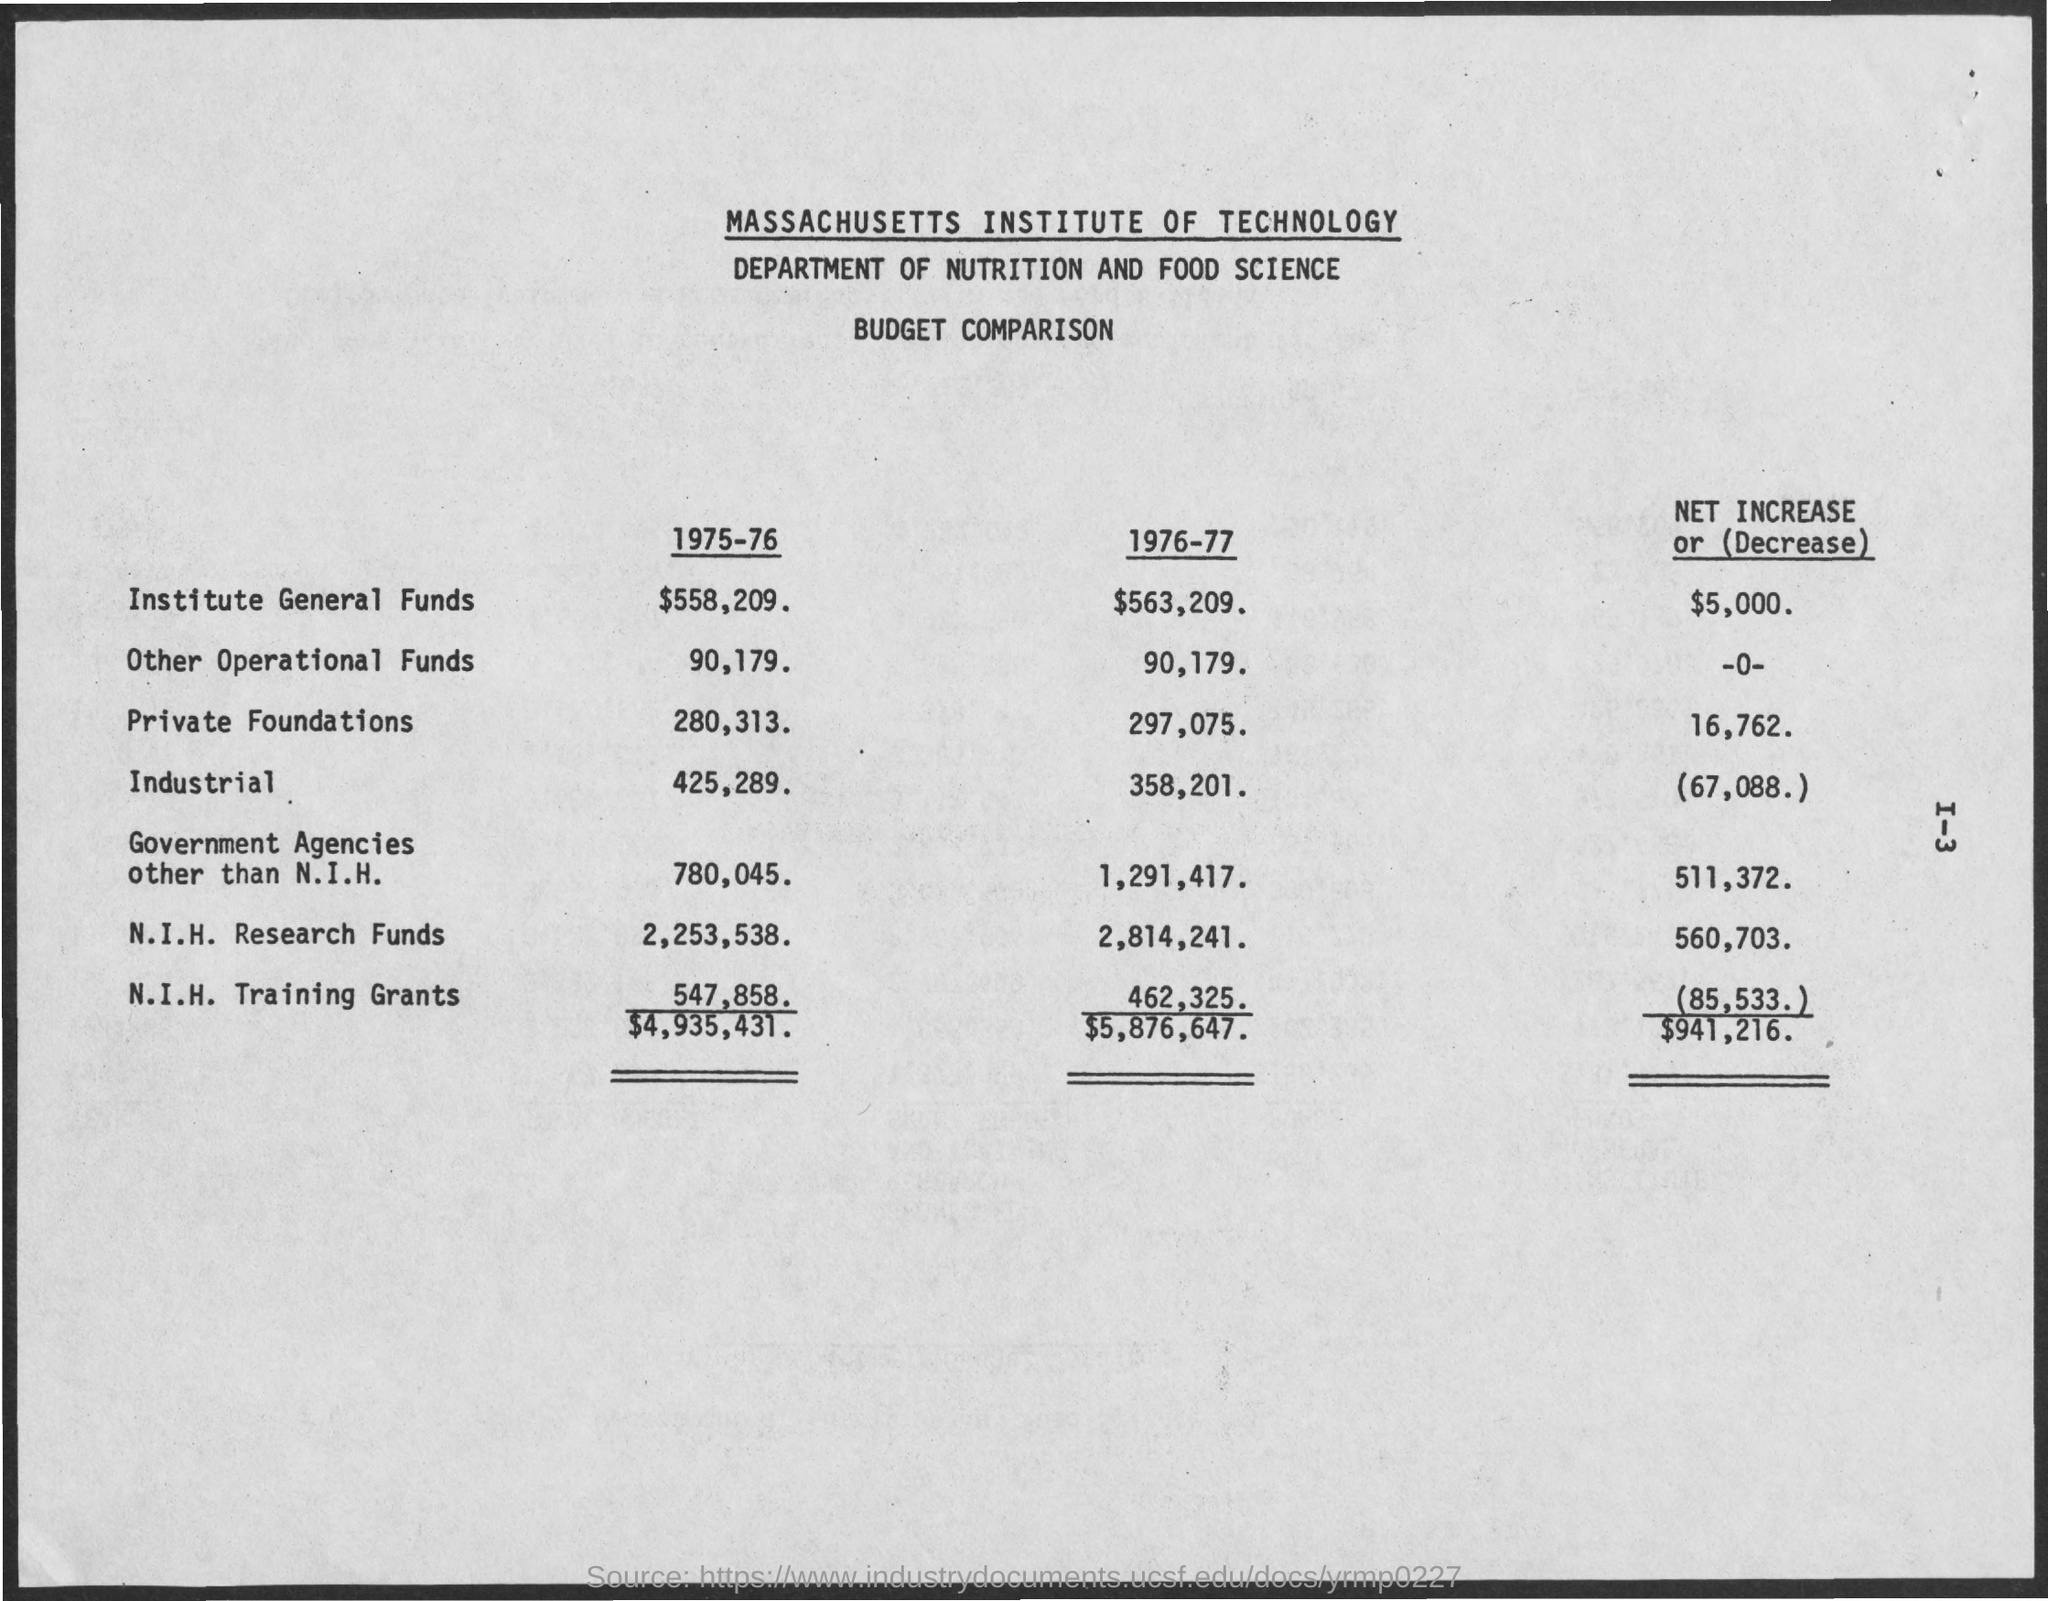What was the percentage increase in N.I.H. Research Funds from 1975-76 to 1976-77? The N.I.H. Research Funds increased from $2,253,538 in 1975-76 to $2,814,241 in 1976-77. This is an increase of $560,703, which approximately constitutes a 24.87% increase in funds year over year. 